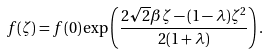Convert formula to latex. <formula><loc_0><loc_0><loc_500><loc_500>f ( \zeta ) = f ( 0 ) \exp \left ( \frac { 2 \sqrt { 2 } \beta \zeta - ( 1 - \lambda ) { \zeta } ^ { 2 } } { 2 ( 1 + \lambda ) } \right ) .</formula> 